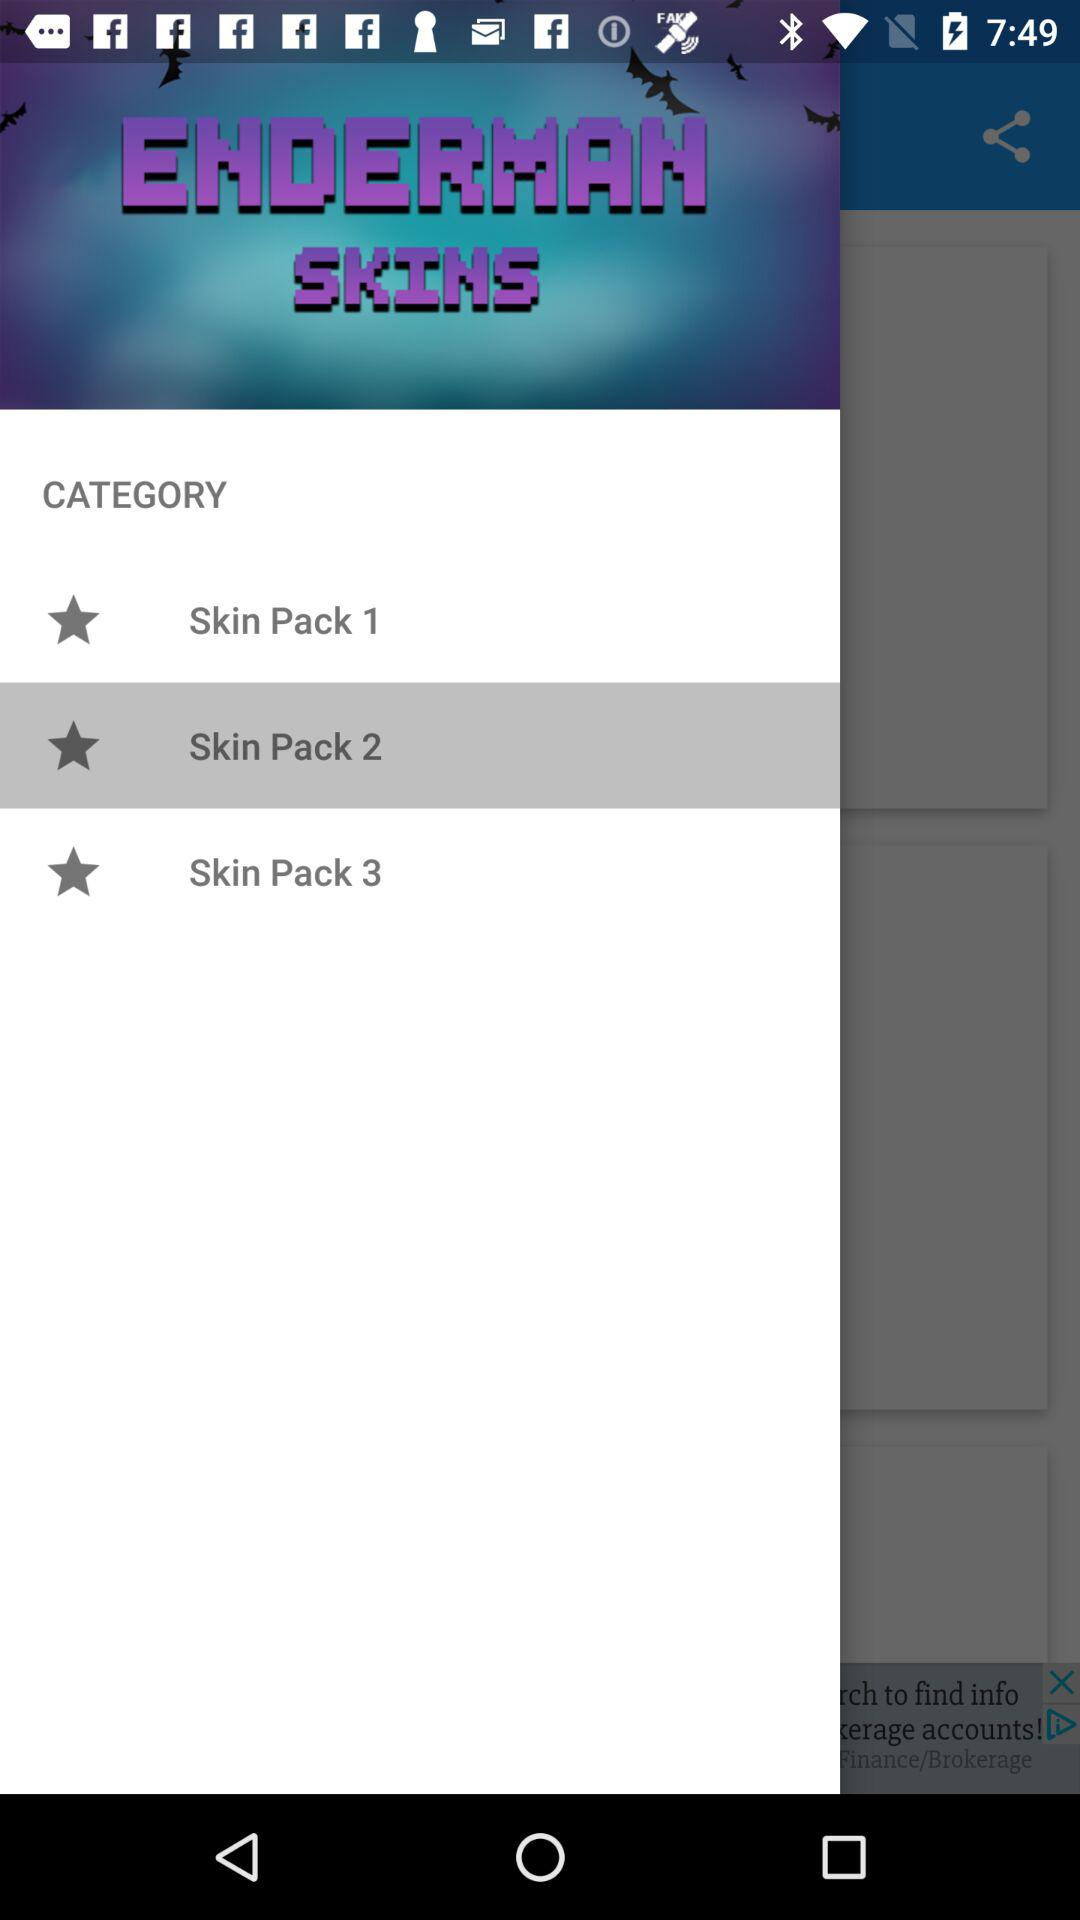Which option is selected? The selected option is "Skin Pack 2". 